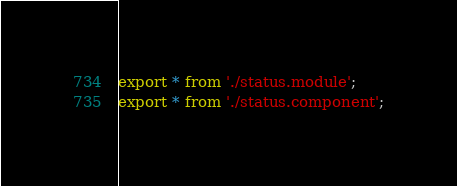Convert code to text. <code><loc_0><loc_0><loc_500><loc_500><_TypeScript_>export * from './status.module';
export * from './status.component';
</code> 